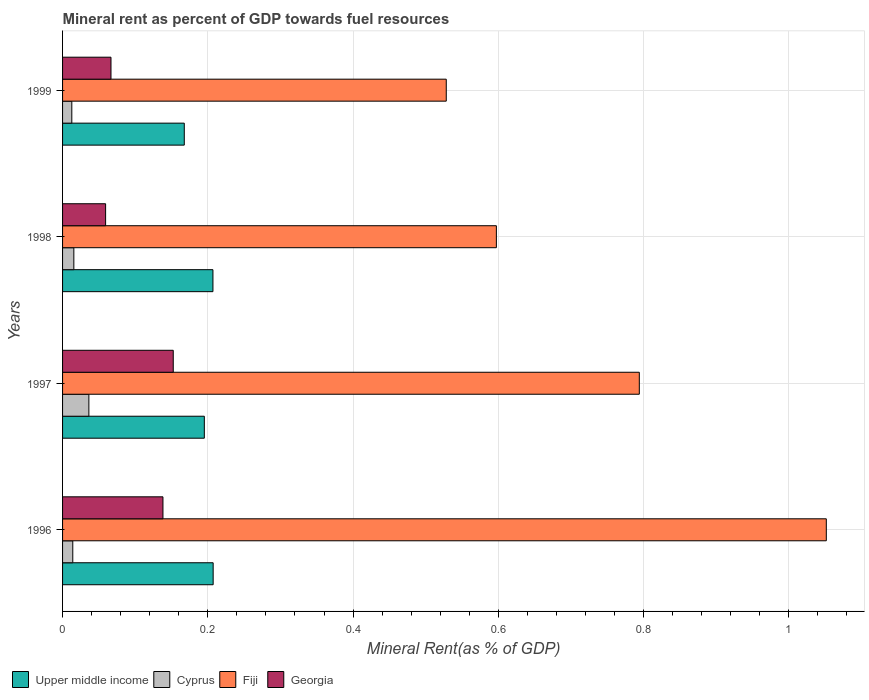Are the number of bars per tick equal to the number of legend labels?
Provide a succinct answer. Yes. How many bars are there on the 1st tick from the bottom?
Provide a short and direct response. 4. What is the mineral rent in Cyprus in 1996?
Your answer should be very brief. 0.01. Across all years, what is the maximum mineral rent in Cyprus?
Your answer should be very brief. 0.04. Across all years, what is the minimum mineral rent in Cyprus?
Ensure brevity in your answer.  0.01. In which year was the mineral rent in Georgia minimum?
Your answer should be compact. 1998. What is the total mineral rent in Upper middle income in the graph?
Make the answer very short. 0.78. What is the difference between the mineral rent in Cyprus in 1996 and that in 1999?
Offer a very short reply. 0. What is the difference between the mineral rent in Georgia in 1996 and the mineral rent in Fiji in 1999?
Ensure brevity in your answer.  -0.39. What is the average mineral rent in Upper middle income per year?
Provide a succinct answer. 0.19. In the year 1997, what is the difference between the mineral rent in Fiji and mineral rent in Upper middle income?
Your answer should be very brief. 0.6. In how many years, is the mineral rent in Fiji greater than 0.48000000000000004 %?
Your answer should be very brief. 4. What is the ratio of the mineral rent in Fiji in 1997 to that in 1998?
Ensure brevity in your answer.  1.33. Is the difference between the mineral rent in Fiji in 1998 and 1999 greater than the difference between the mineral rent in Upper middle income in 1998 and 1999?
Make the answer very short. Yes. What is the difference between the highest and the second highest mineral rent in Upper middle income?
Your answer should be very brief. 0. What is the difference between the highest and the lowest mineral rent in Georgia?
Provide a short and direct response. 0.09. Is the sum of the mineral rent in Fiji in 1996 and 1997 greater than the maximum mineral rent in Georgia across all years?
Offer a terse response. Yes. Is it the case that in every year, the sum of the mineral rent in Fiji and mineral rent in Upper middle income is greater than the sum of mineral rent in Cyprus and mineral rent in Georgia?
Provide a succinct answer. Yes. What does the 1st bar from the top in 1998 represents?
Keep it short and to the point. Georgia. What does the 4th bar from the bottom in 1996 represents?
Your answer should be compact. Georgia. Is it the case that in every year, the sum of the mineral rent in Cyprus and mineral rent in Georgia is greater than the mineral rent in Fiji?
Ensure brevity in your answer.  No. Does the graph contain any zero values?
Provide a succinct answer. No. Where does the legend appear in the graph?
Give a very brief answer. Bottom left. What is the title of the graph?
Offer a very short reply. Mineral rent as percent of GDP towards fuel resources. Does "Dominica" appear as one of the legend labels in the graph?
Make the answer very short. No. What is the label or title of the X-axis?
Offer a terse response. Mineral Rent(as % of GDP). What is the label or title of the Y-axis?
Ensure brevity in your answer.  Years. What is the Mineral Rent(as % of GDP) in Upper middle income in 1996?
Your response must be concise. 0.21. What is the Mineral Rent(as % of GDP) in Cyprus in 1996?
Make the answer very short. 0.01. What is the Mineral Rent(as % of GDP) of Fiji in 1996?
Give a very brief answer. 1.05. What is the Mineral Rent(as % of GDP) in Georgia in 1996?
Ensure brevity in your answer.  0.14. What is the Mineral Rent(as % of GDP) in Upper middle income in 1997?
Your answer should be very brief. 0.2. What is the Mineral Rent(as % of GDP) of Cyprus in 1997?
Your answer should be very brief. 0.04. What is the Mineral Rent(as % of GDP) in Fiji in 1997?
Your response must be concise. 0.79. What is the Mineral Rent(as % of GDP) of Georgia in 1997?
Make the answer very short. 0.15. What is the Mineral Rent(as % of GDP) in Upper middle income in 1998?
Offer a very short reply. 0.21. What is the Mineral Rent(as % of GDP) in Cyprus in 1998?
Provide a succinct answer. 0.02. What is the Mineral Rent(as % of GDP) in Fiji in 1998?
Offer a very short reply. 0.6. What is the Mineral Rent(as % of GDP) of Georgia in 1998?
Offer a very short reply. 0.06. What is the Mineral Rent(as % of GDP) in Upper middle income in 1999?
Ensure brevity in your answer.  0.17. What is the Mineral Rent(as % of GDP) of Cyprus in 1999?
Make the answer very short. 0.01. What is the Mineral Rent(as % of GDP) of Fiji in 1999?
Your answer should be very brief. 0.53. What is the Mineral Rent(as % of GDP) in Georgia in 1999?
Your answer should be compact. 0.07. Across all years, what is the maximum Mineral Rent(as % of GDP) of Upper middle income?
Offer a terse response. 0.21. Across all years, what is the maximum Mineral Rent(as % of GDP) of Cyprus?
Your answer should be very brief. 0.04. Across all years, what is the maximum Mineral Rent(as % of GDP) in Fiji?
Provide a short and direct response. 1.05. Across all years, what is the maximum Mineral Rent(as % of GDP) of Georgia?
Give a very brief answer. 0.15. Across all years, what is the minimum Mineral Rent(as % of GDP) of Upper middle income?
Give a very brief answer. 0.17. Across all years, what is the minimum Mineral Rent(as % of GDP) in Cyprus?
Ensure brevity in your answer.  0.01. Across all years, what is the minimum Mineral Rent(as % of GDP) in Fiji?
Your answer should be very brief. 0.53. Across all years, what is the minimum Mineral Rent(as % of GDP) of Georgia?
Give a very brief answer. 0.06. What is the total Mineral Rent(as % of GDP) of Upper middle income in the graph?
Your answer should be very brief. 0.78. What is the total Mineral Rent(as % of GDP) of Cyprus in the graph?
Keep it short and to the point. 0.08. What is the total Mineral Rent(as % of GDP) in Fiji in the graph?
Ensure brevity in your answer.  2.97. What is the total Mineral Rent(as % of GDP) of Georgia in the graph?
Give a very brief answer. 0.42. What is the difference between the Mineral Rent(as % of GDP) in Upper middle income in 1996 and that in 1997?
Make the answer very short. 0.01. What is the difference between the Mineral Rent(as % of GDP) in Cyprus in 1996 and that in 1997?
Provide a succinct answer. -0.02. What is the difference between the Mineral Rent(as % of GDP) of Fiji in 1996 and that in 1997?
Keep it short and to the point. 0.26. What is the difference between the Mineral Rent(as % of GDP) of Georgia in 1996 and that in 1997?
Keep it short and to the point. -0.01. What is the difference between the Mineral Rent(as % of GDP) of Upper middle income in 1996 and that in 1998?
Provide a succinct answer. 0. What is the difference between the Mineral Rent(as % of GDP) of Cyprus in 1996 and that in 1998?
Your response must be concise. -0. What is the difference between the Mineral Rent(as % of GDP) of Fiji in 1996 and that in 1998?
Ensure brevity in your answer.  0.45. What is the difference between the Mineral Rent(as % of GDP) of Georgia in 1996 and that in 1998?
Make the answer very short. 0.08. What is the difference between the Mineral Rent(as % of GDP) in Upper middle income in 1996 and that in 1999?
Give a very brief answer. 0.04. What is the difference between the Mineral Rent(as % of GDP) in Cyprus in 1996 and that in 1999?
Provide a succinct answer. 0. What is the difference between the Mineral Rent(as % of GDP) in Fiji in 1996 and that in 1999?
Give a very brief answer. 0.52. What is the difference between the Mineral Rent(as % of GDP) in Georgia in 1996 and that in 1999?
Your response must be concise. 0.07. What is the difference between the Mineral Rent(as % of GDP) of Upper middle income in 1997 and that in 1998?
Give a very brief answer. -0.01. What is the difference between the Mineral Rent(as % of GDP) of Cyprus in 1997 and that in 1998?
Your answer should be compact. 0.02. What is the difference between the Mineral Rent(as % of GDP) in Fiji in 1997 and that in 1998?
Ensure brevity in your answer.  0.2. What is the difference between the Mineral Rent(as % of GDP) of Georgia in 1997 and that in 1998?
Offer a terse response. 0.09. What is the difference between the Mineral Rent(as % of GDP) in Upper middle income in 1997 and that in 1999?
Keep it short and to the point. 0.03. What is the difference between the Mineral Rent(as % of GDP) of Cyprus in 1997 and that in 1999?
Your answer should be compact. 0.02. What is the difference between the Mineral Rent(as % of GDP) in Fiji in 1997 and that in 1999?
Give a very brief answer. 0.27. What is the difference between the Mineral Rent(as % of GDP) of Georgia in 1997 and that in 1999?
Give a very brief answer. 0.09. What is the difference between the Mineral Rent(as % of GDP) in Upper middle income in 1998 and that in 1999?
Your response must be concise. 0.04. What is the difference between the Mineral Rent(as % of GDP) of Cyprus in 1998 and that in 1999?
Ensure brevity in your answer.  0. What is the difference between the Mineral Rent(as % of GDP) of Fiji in 1998 and that in 1999?
Make the answer very short. 0.07. What is the difference between the Mineral Rent(as % of GDP) in Georgia in 1998 and that in 1999?
Your answer should be compact. -0.01. What is the difference between the Mineral Rent(as % of GDP) in Upper middle income in 1996 and the Mineral Rent(as % of GDP) in Cyprus in 1997?
Your answer should be very brief. 0.17. What is the difference between the Mineral Rent(as % of GDP) in Upper middle income in 1996 and the Mineral Rent(as % of GDP) in Fiji in 1997?
Ensure brevity in your answer.  -0.59. What is the difference between the Mineral Rent(as % of GDP) in Upper middle income in 1996 and the Mineral Rent(as % of GDP) in Georgia in 1997?
Provide a succinct answer. 0.05. What is the difference between the Mineral Rent(as % of GDP) of Cyprus in 1996 and the Mineral Rent(as % of GDP) of Fiji in 1997?
Give a very brief answer. -0.78. What is the difference between the Mineral Rent(as % of GDP) in Cyprus in 1996 and the Mineral Rent(as % of GDP) in Georgia in 1997?
Provide a short and direct response. -0.14. What is the difference between the Mineral Rent(as % of GDP) of Fiji in 1996 and the Mineral Rent(as % of GDP) of Georgia in 1997?
Your answer should be very brief. 0.9. What is the difference between the Mineral Rent(as % of GDP) of Upper middle income in 1996 and the Mineral Rent(as % of GDP) of Cyprus in 1998?
Offer a terse response. 0.19. What is the difference between the Mineral Rent(as % of GDP) of Upper middle income in 1996 and the Mineral Rent(as % of GDP) of Fiji in 1998?
Your response must be concise. -0.39. What is the difference between the Mineral Rent(as % of GDP) of Upper middle income in 1996 and the Mineral Rent(as % of GDP) of Georgia in 1998?
Provide a succinct answer. 0.15. What is the difference between the Mineral Rent(as % of GDP) of Cyprus in 1996 and the Mineral Rent(as % of GDP) of Fiji in 1998?
Give a very brief answer. -0.58. What is the difference between the Mineral Rent(as % of GDP) in Cyprus in 1996 and the Mineral Rent(as % of GDP) in Georgia in 1998?
Keep it short and to the point. -0.05. What is the difference between the Mineral Rent(as % of GDP) of Upper middle income in 1996 and the Mineral Rent(as % of GDP) of Cyprus in 1999?
Your response must be concise. 0.19. What is the difference between the Mineral Rent(as % of GDP) of Upper middle income in 1996 and the Mineral Rent(as % of GDP) of Fiji in 1999?
Your answer should be compact. -0.32. What is the difference between the Mineral Rent(as % of GDP) in Upper middle income in 1996 and the Mineral Rent(as % of GDP) in Georgia in 1999?
Give a very brief answer. 0.14. What is the difference between the Mineral Rent(as % of GDP) of Cyprus in 1996 and the Mineral Rent(as % of GDP) of Fiji in 1999?
Your answer should be compact. -0.51. What is the difference between the Mineral Rent(as % of GDP) in Cyprus in 1996 and the Mineral Rent(as % of GDP) in Georgia in 1999?
Your answer should be very brief. -0.05. What is the difference between the Mineral Rent(as % of GDP) in Fiji in 1996 and the Mineral Rent(as % of GDP) in Georgia in 1999?
Keep it short and to the point. 0.98. What is the difference between the Mineral Rent(as % of GDP) in Upper middle income in 1997 and the Mineral Rent(as % of GDP) in Cyprus in 1998?
Offer a very short reply. 0.18. What is the difference between the Mineral Rent(as % of GDP) in Upper middle income in 1997 and the Mineral Rent(as % of GDP) in Fiji in 1998?
Provide a succinct answer. -0.4. What is the difference between the Mineral Rent(as % of GDP) in Upper middle income in 1997 and the Mineral Rent(as % of GDP) in Georgia in 1998?
Your answer should be compact. 0.14. What is the difference between the Mineral Rent(as % of GDP) of Cyprus in 1997 and the Mineral Rent(as % of GDP) of Fiji in 1998?
Ensure brevity in your answer.  -0.56. What is the difference between the Mineral Rent(as % of GDP) in Cyprus in 1997 and the Mineral Rent(as % of GDP) in Georgia in 1998?
Offer a terse response. -0.02. What is the difference between the Mineral Rent(as % of GDP) of Fiji in 1997 and the Mineral Rent(as % of GDP) of Georgia in 1998?
Give a very brief answer. 0.73. What is the difference between the Mineral Rent(as % of GDP) of Upper middle income in 1997 and the Mineral Rent(as % of GDP) of Cyprus in 1999?
Ensure brevity in your answer.  0.18. What is the difference between the Mineral Rent(as % of GDP) of Upper middle income in 1997 and the Mineral Rent(as % of GDP) of Fiji in 1999?
Keep it short and to the point. -0.33. What is the difference between the Mineral Rent(as % of GDP) in Upper middle income in 1997 and the Mineral Rent(as % of GDP) in Georgia in 1999?
Give a very brief answer. 0.13. What is the difference between the Mineral Rent(as % of GDP) of Cyprus in 1997 and the Mineral Rent(as % of GDP) of Fiji in 1999?
Your response must be concise. -0.49. What is the difference between the Mineral Rent(as % of GDP) in Cyprus in 1997 and the Mineral Rent(as % of GDP) in Georgia in 1999?
Provide a succinct answer. -0.03. What is the difference between the Mineral Rent(as % of GDP) in Fiji in 1997 and the Mineral Rent(as % of GDP) in Georgia in 1999?
Keep it short and to the point. 0.73. What is the difference between the Mineral Rent(as % of GDP) of Upper middle income in 1998 and the Mineral Rent(as % of GDP) of Cyprus in 1999?
Provide a short and direct response. 0.19. What is the difference between the Mineral Rent(as % of GDP) in Upper middle income in 1998 and the Mineral Rent(as % of GDP) in Fiji in 1999?
Offer a terse response. -0.32. What is the difference between the Mineral Rent(as % of GDP) of Upper middle income in 1998 and the Mineral Rent(as % of GDP) of Georgia in 1999?
Your response must be concise. 0.14. What is the difference between the Mineral Rent(as % of GDP) in Cyprus in 1998 and the Mineral Rent(as % of GDP) in Fiji in 1999?
Provide a short and direct response. -0.51. What is the difference between the Mineral Rent(as % of GDP) in Cyprus in 1998 and the Mineral Rent(as % of GDP) in Georgia in 1999?
Give a very brief answer. -0.05. What is the difference between the Mineral Rent(as % of GDP) of Fiji in 1998 and the Mineral Rent(as % of GDP) of Georgia in 1999?
Make the answer very short. 0.53. What is the average Mineral Rent(as % of GDP) of Upper middle income per year?
Provide a succinct answer. 0.19. What is the average Mineral Rent(as % of GDP) of Cyprus per year?
Keep it short and to the point. 0.02. What is the average Mineral Rent(as % of GDP) of Fiji per year?
Your response must be concise. 0.74. What is the average Mineral Rent(as % of GDP) in Georgia per year?
Make the answer very short. 0.1. In the year 1996, what is the difference between the Mineral Rent(as % of GDP) in Upper middle income and Mineral Rent(as % of GDP) in Cyprus?
Your answer should be very brief. 0.19. In the year 1996, what is the difference between the Mineral Rent(as % of GDP) of Upper middle income and Mineral Rent(as % of GDP) of Fiji?
Your answer should be compact. -0.84. In the year 1996, what is the difference between the Mineral Rent(as % of GDP) of Upper middle income and Mineral Rent(as % of GDP) of Georgia?
Make the answer very short. 0.07. In the year 1996, what is the difference between the Mineral Rent(as % of GDP) of Cyprus and Mineral Rent(as % of GDP) of Fiji?
Offer a terse response. -1.04. In the year 1996, what is the difference between the Mineral Rent(as % of GDP) of Cyprus and Mineral Rent(as % of GDP) of Georgia?
Offer a terse response. -0.12. In the year 1996, what is the difference between the Mineral Rent(as % of GDP) of Fiji and Mineral Rent(as % of GDP) of Georgia?
Your answer should be very brief. 0.91. In the year 1997, what is the difference between the Mineral Rent(as % of GDP) in Upper middle income and Mineral Rent(as % of GDP) in Cyprus?
Your answer should be very brief. 0.16. In the year 1997, what is the difference between the Mineral Rent(as % of GDP) in Upper middle income and Mineral Rent(as % of GDP) in Fiji?
Offer a terse response. -0.6. In the year 1997, what is the difference between the Mineral Rent(as % of GDP) of Upper middle income and Mineral Rent(as % of GDP) of Georgia?
Keep it short and to the point. 0.04. In the year 1997, what is the difference between the Mineral Rent(as % of GDP) in Cyprus and Mineral Rent(as % of GDP) in Fiji?
Offer a terse response. -0.76. In the year 1997, what is the difference between the Mineral Rent(as % of GDP) of Cyprus and Mineral Rent(as % of GDP) of Georgia?
Your answer should be compact. -0.12. In the year 1997, what is the difference between the Mineral Rent(as % of GDP) in Fiji and Mineral Rent(as % of GDP) in Georgia?
Provide a short and direct response. 0.64. In the year 1998, what is the difference between the Mineral Rent(as % of GDP) of Upper middle income and Mineral Rent(as % of GDP) of Cyprus?
Your response must be concise. 0.19. In the year 1998, what is the difference between the Mineral Rent(as % of GDP) in Upper middle income and Mineral Rent(as % of GDP) in Fiji?
Offer a terse response. -0.39. In the year 1998, what is the difference between the Mineral Rent(as % of GDP) in Upper middle income and Mineral Rent(as % of GDP) in Georgia?
Make the answer very short. 0.15. In the year 1998, what is the difference between the Mineral Rent(as % of GDP) of Cyprus and Mineral Rent(as % of GDP) of Fiji?
Ensure brevity in your answer.  -0.58. In the year 1998, what is the difference between the Mineral Rent(as % of GDP) in Cyprus and Mineral Rent(as % of GDP) in Georgia?
Make the answer very short. -0.04. In the year 1998, what is the difference between the Mineral Rent(as % of GDP) of Fiji and Mineral Rent(as % of GDP) of Georgia?
Offer a very short reply. 0.54. In the year 1999, what is the difference between the Mineral Rent(as % of GDP) in Upper middle income and Mineral Rent(as % of GDP) in Cyprus?
Offer a very short reply. 0.15. In the year 1999, what is the difference between the Mineral Rent(as % of GDP) of Upper middle income and Mineral Rent(as % of GDP) of Fiji?
Make the answer very short. -0.36. In the year 1999, what is the difference between the Mineral Rent(as % of GDP) of Upper middle income and Mineral Rent(as % of GDP) of Georgia?
Your response must be concise. 0.1. In the year 1999, what is the difference between the Mineral Rent(as % of GDP) in Cyprus and Mineral Rent(as % of GDP) in Fiji?
Offer a terse response. -0.52. In the year 1999, what is the difference between the Mineral Rent(as % of GDP) in Cyprus and Mineral Rent(as % of GDP) in Georgia?
Your answer should be very brief. -0.05. In the year 1999, what is the difference between the Mineral Rent(as % of GDP) in Fiji and Mineral Rent(as % of GDP) in Georgia?
Offer a terse response. 0.46. What is the ratio of the Mineral Rent(as % of GDP) in Upper middle income in 1996 to that in 1997?
Offer a terse response. 1.06. What is the ratio of the Mineral Rent(as % of GDP) of Cyprus in 1996 to that in 1997?
Give a very brief answer. 0.39. What is the ratio of the Mineral Rent(as % of GDP) in Fiji in 1996 to that in 1997?
Ensure brevity in your answer.  1.32. What is the ratio of the Mineral Rent(as % of GDP) of Georgia in 1996 to that in 1997?
Offer a very short reply. 0.91. What is the ratio of the Mineral Rent(as % of GDP) of Upper middle income in 1996 to that in 1998?
Your response must be concise. 1. What is the ratio of the Mineral Rent(as % of GDP) of Cyprus in 1996 to that in 1998?
Provide a short and direct response. 0.91. What is the ratio of the Mineral Rent(as % of GDP) of Fiji in 1996 to that in 1998?
Offer a terse response. 1.76. What is the ratio of the Mineral Rent(as % of GDP) of Georgia in 1996 to that in 1998?
Your response must be concise. 2.33. What is the ratio of the Mineral Rent(as % of GDP) in Upper middle income in 1996 to that in 1999?
Provide a short and direct response. 1.24. What is the ratio of the Mineral Rent(as % of GDP) of Cyprus in 1996 to that in 1999?
Ensure brevity in your answer.  1.11. What is the ratio of the Mineral Rent(as % of GDP) of Fiji in 1996 to that in 1999?
Your answer should be compact. 1.99. What is the ratio of the Mineral Rent(as % of GDP) of Georgia in 1996 to that in 1999?
Provide a succinct answer. 2.07. What is the ratio of the Mineral Rent(as % of GDP) of Upper middle income in 1997 to that in 1998?
Offer a terse response. 0.94. What is the ratio of the Mineral Rent(as % of GDP) in Cyprus in 1997 to that in 1998?
Keep it short and to the point. 2.33. What is the ratio of the Mineral Rent(as % of GDP) in Fiji in 1997 to that in 1998?
Your answer should be very brief. 1.33. What is the ratio of the Mineral Rent(as % of GDP) of Georgia in 1997 to that in 1998?
Offer a terse response. 2.57. What is the ratio of the Mineral Rent(as % of GDP) in Upper middle income in 1997 to that in 1999?
Offer a terse response. 1.16. What is the ratio of the Mineral Rent(as % of GDP) of Cyprus in 1997 to that in 1999?
Ensure brevity in your answer.  2.85. What is the ratio of the Mineral Rent(as % of GDP) of Fiji in 1997 to that in 1999?
Ensure brevity in your answer.  1.5. What is the ratio of the Mineral Rent(as % of GDP) of Georgia in 1997 to that in 1999?
Offer a very short reply. 2.29. What is the ratio of the Mineral Rent(as % of GDP) in Upper middle income in 1998 to that in 1999?
Offer a terse response. 1.24. What is the ratio of the Mineral Rent(as % of GDP) in Cyprus in 1998 to that in 1999?
Your answer should be compact. 1.22. What is the ratio of the Mineral Rent(as % of GDP) of Fiji in 1998 to that in 1999?
Offer a terse response. 1.13. What is the ratio of the Mineral Rent(as % of GDP) of Georgia in 1998 to that in 1999?
Offer a terse response. 0.89. What is the difference between the highest and the second highest Mineral Rent(as % of GDP) of Upper middle income?
Your answer should be very brief. 0. What is the difference between the highest and the second highest Mineral Rent(as % of GDP) in Cyprus?
Ensure brevity in your answer.  0.02. What is the difference between the highest and the second highest Mineral Rent(as % of GDP) of Fiji?
Ensure brevity in your answer.  0.26. What is the difference between the highest and the second highest Mineral Rent(as % of GDP) of Georgia?
Provide a succinct answer. 0.01. What is the difference between the highest and the lowest Mineral Rent(as % of GDP) in Upper middle income?
Give a very brief answer. 0.04. What is the difference between the highest and the lowest Mineral Rent(as % of GDP) of Cyprus?
Offer a terse response. 0.02. What is the difference between the highest and the lowest Mineral Rent(as % of GDP) of Fiji?
Make the answer very short. 0.52. What is the difference between the highest and the lowest Mineral Rent(as % of GDP) in Georgia?
Provide a short and direct response. 0.09. 